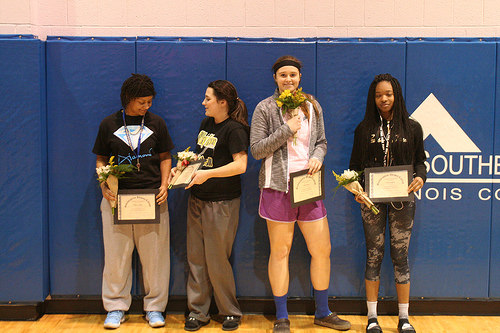<image>
Is there a flowers under the person face? No. The flowers is not positioned under the person face. The vertical relationship between these objects is different. 